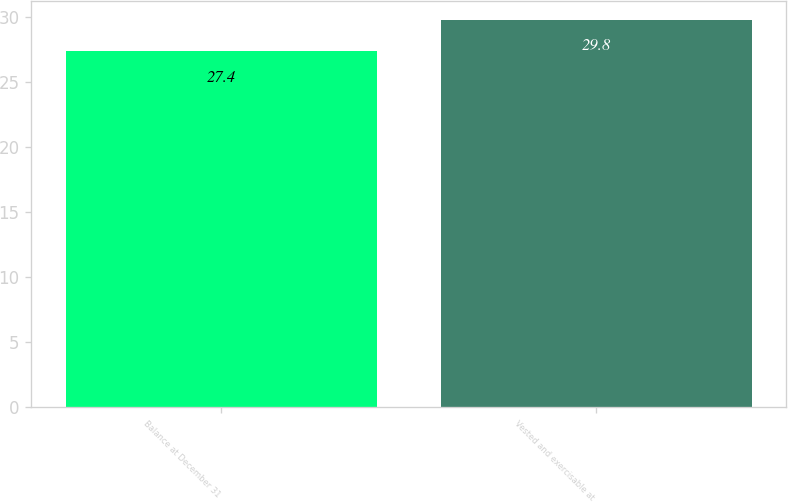Convert chart. <chart><loc_0><loc_0><loc_500><loc_500><bar_chart><fcel>Balance at December 31<fcel>Vested and exercisable at<nl><fcel>27.4<fcel>29.8<nl></chart> 